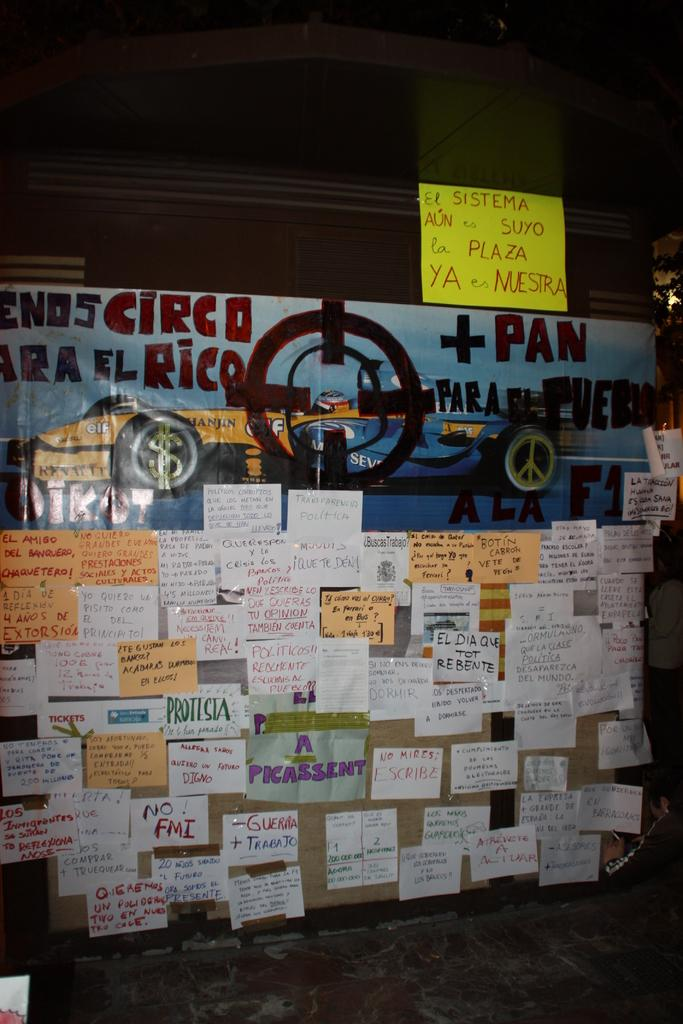What is present on the wall in the image? Papers are attached to the wall in the image. What color is at the top of the image? There is a black color at the top of the image. How many children are playing with the goat in the image? There is no goat or children present in the image. What type of sound can be heard coming from the wall in the image? There is no sound coming from the wall in the image. 